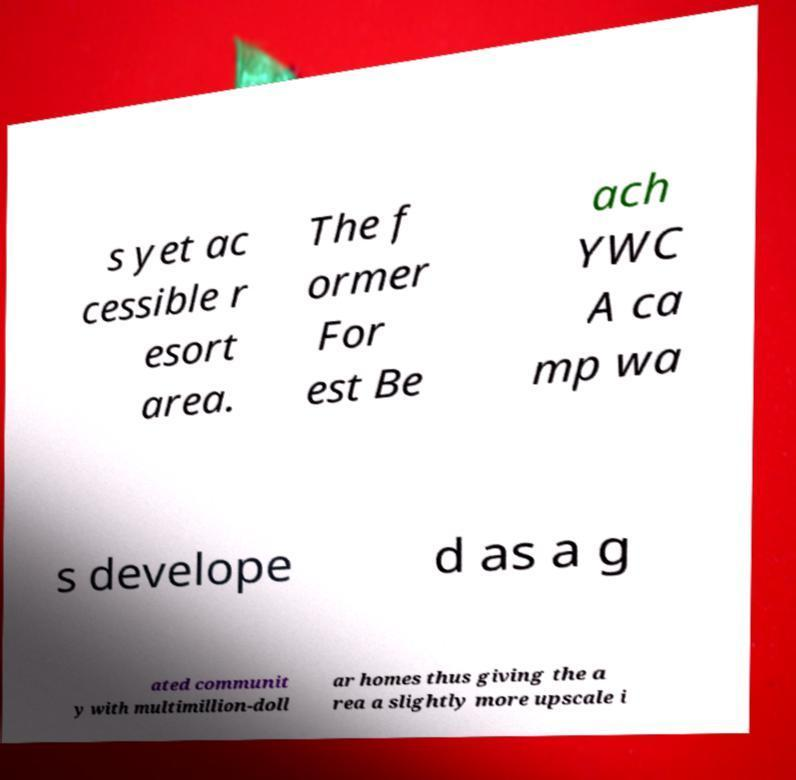Can you read and provide the text displayed in the image?This photo seems to have some interesting text. Can you extract and type it out for me? s yet ac cessible r esort area. The f ormer For est Be ach YWC A ca mp wa s develope d as a g ated communit y with multimillion-doll ar homes thus giving the a rea a slightly more upscale i 